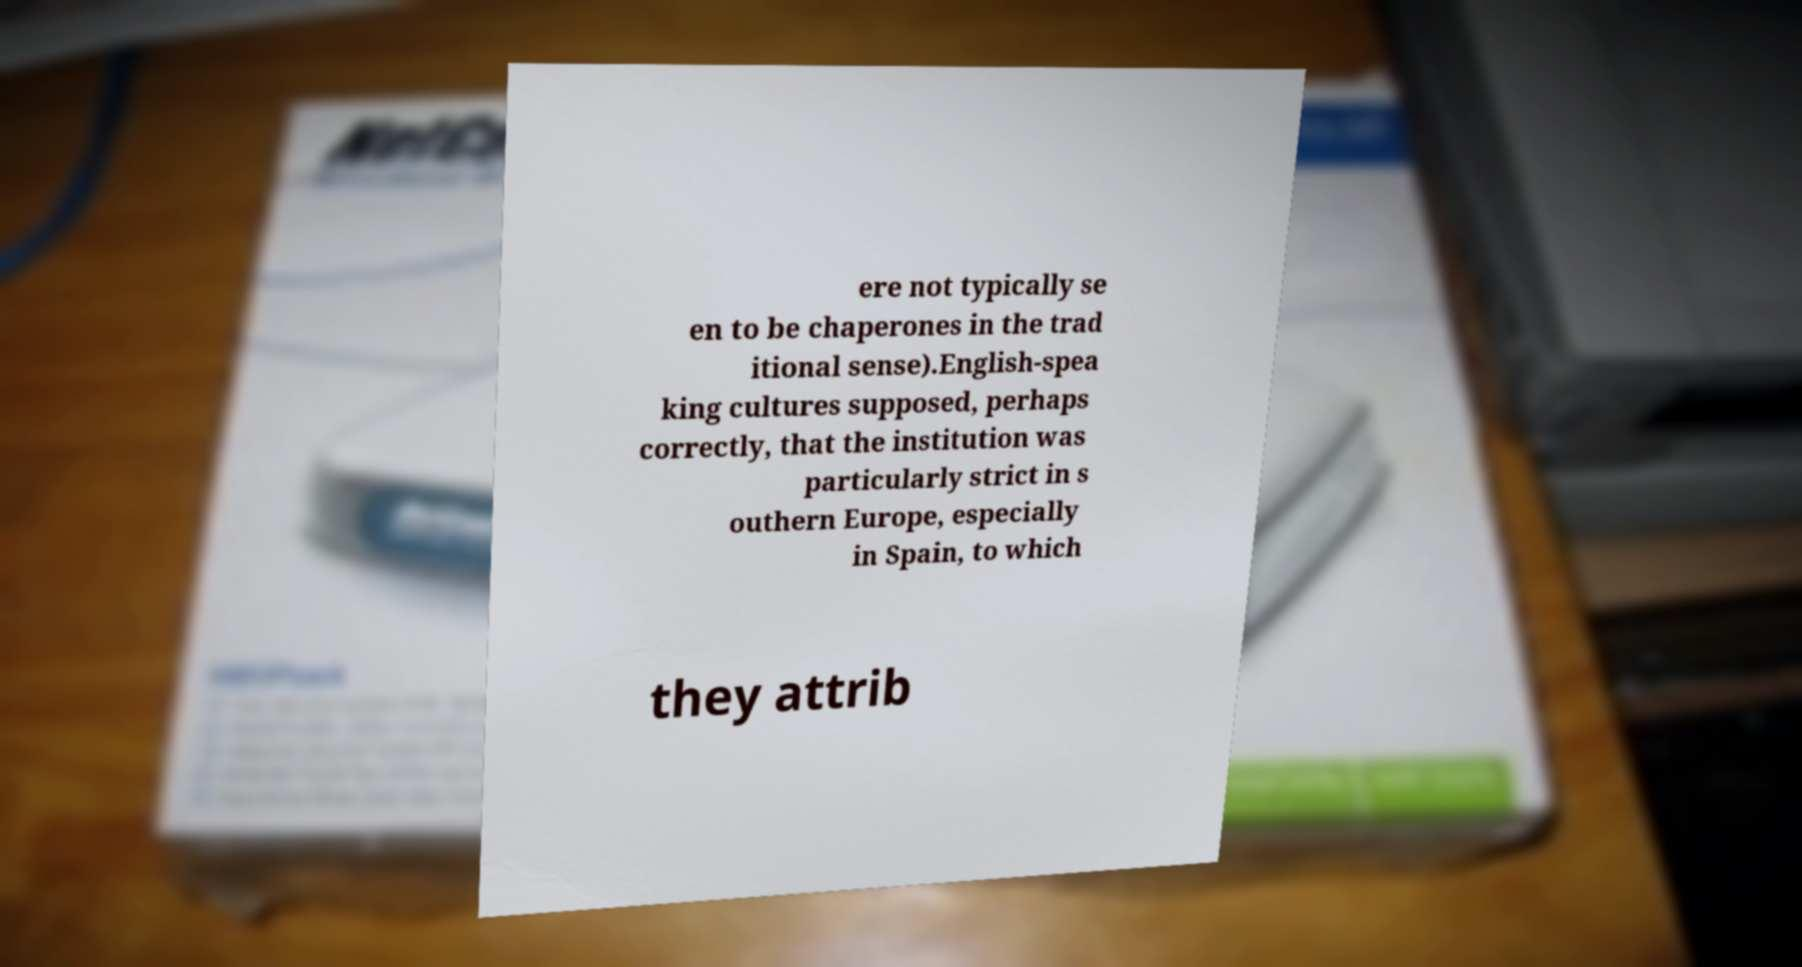Can you read and provide the text displayed in the image?This photo seems to have some interesting text. Can you extract and type it out for me? ere not typically se en to be chaperones in the trad itional sense).English-spea king cultures supposed, perhaps correctly, that the institution was particularly strict in s outhern Europe, especially in Spain, to which they attrib 